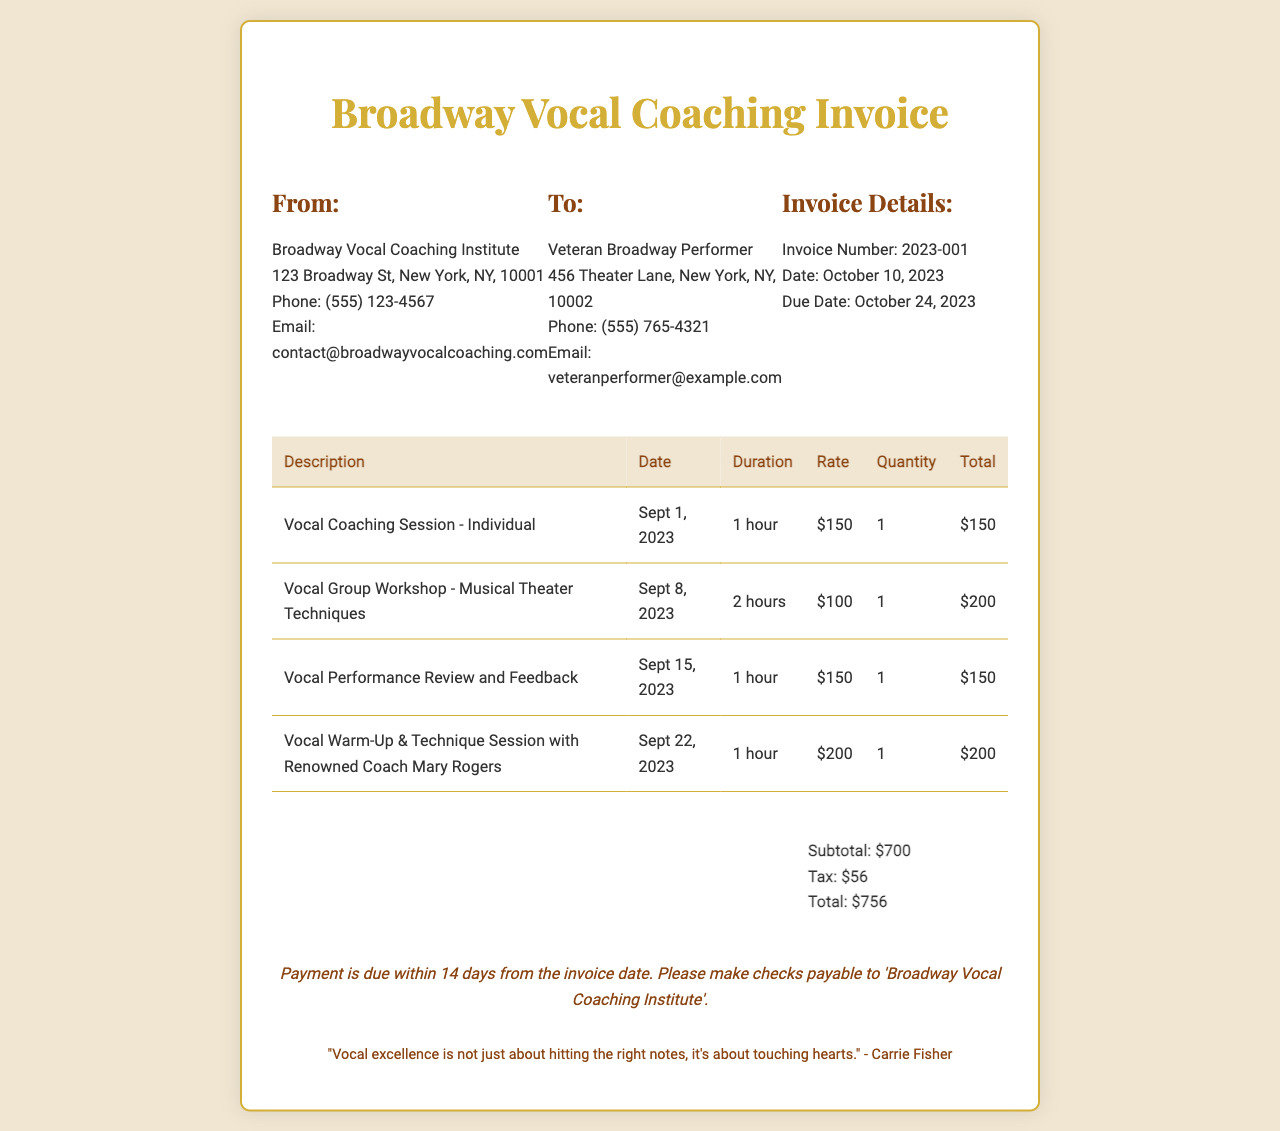What is the invoice number? The invoice number is specified in the document, which is usually unique for tracking purposes.
Answer: 2023-001 What is the total amount due? The total amount due is the final charge that needs to be paid, including any taxes.
Answer: $756 Who is the renowned coach mentioned? The document includes the name of the coach who provided a specific vocal session.
Answer: Mary Rogers What is the date of the first vocal coaching session? The date of the first session is clearly listed in the details of the sessions provided in the table.
Answer: Sept 1, 2023 What is the due date for the payment? The due date is when the payment needs to be made, as stated in the invoice details.
Answer: October 24, 2023 What is the subtotal amount before tax? The subtotal is calculated from the individual session charges before tax is added.
Answer: $700 How many hours was the vocal group workshop? The duration of the vocal group workshop can be found in the table, indicating how long the session lasted.
Answer: 2 hours What is the tax amount? The tax amount is listed separately in the summary section of the invoice and adds to the subtotal.
Answer: $56 What is the payment term specified in the invoice? The payment term indicates the time allowed for payment after the invoice date.
Answer: 14 days 